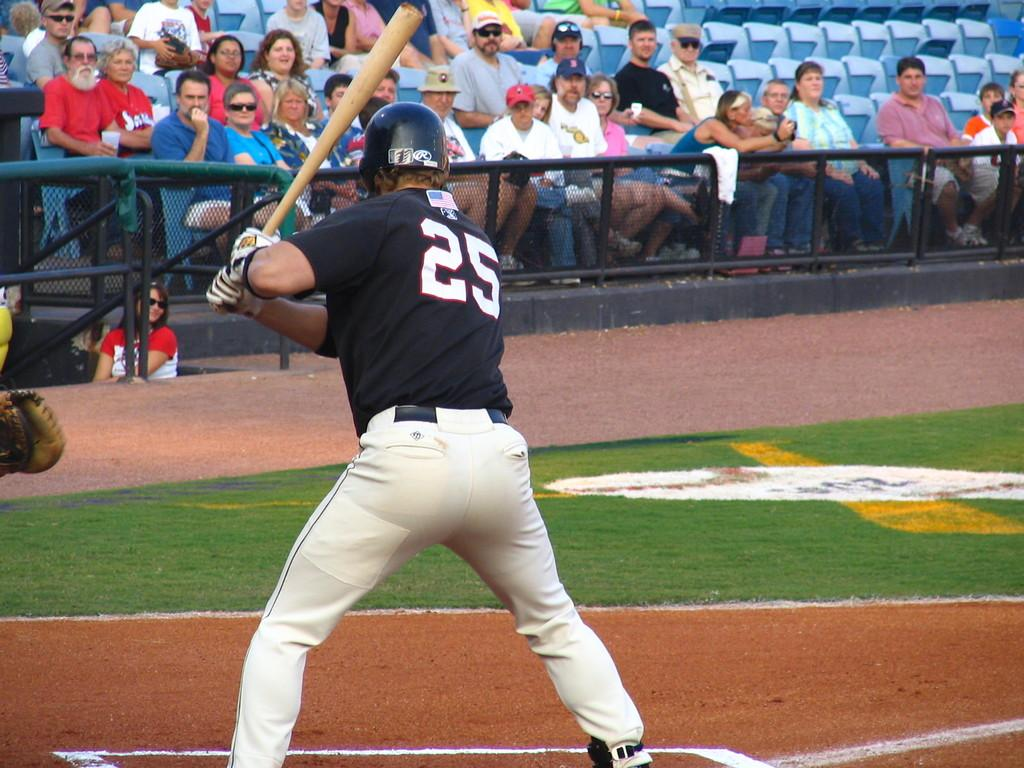<image>
Describe the image concisely. number 25 in blue and white with bat waiting for a pitch in front of sparse crowd 